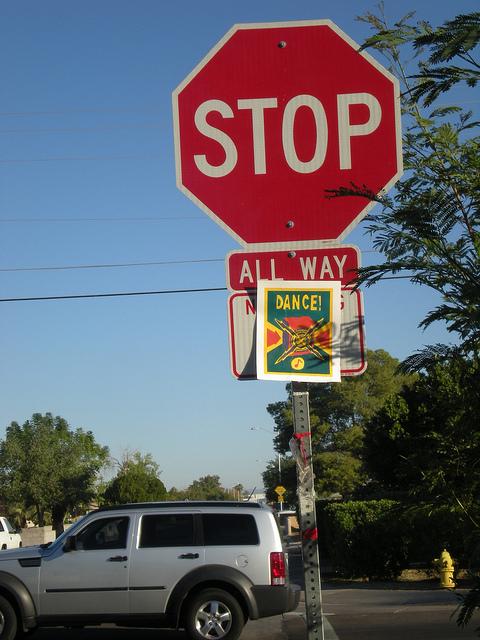What is the color of the closest car?
Quick response, please. Silver. How many wires?
Short answer required. 6. Is there traffic?
Concise answer only. Yes. How many vehicles can be seen?
Answer briefly. 1. What color is the traffic signs?
Concise answer only. Red. What color is the fire hydrant?
Short answer required. Yellow. What country flag is hanging?
Answer briefly. None. How many cars are in the picture?
Give a very brief answer. 1. Can traffic drive through the intersection?
Give a very brief answer. Yes. Is that gray truck a Chevy or a Dodge?
Keep it brief. Dodge. What is on the street?
Answer briefly. Car. What kind of car is in the photo?
Answer briefly. Suv. What is on the back of this sign?
Keep it brief. Flyer. 